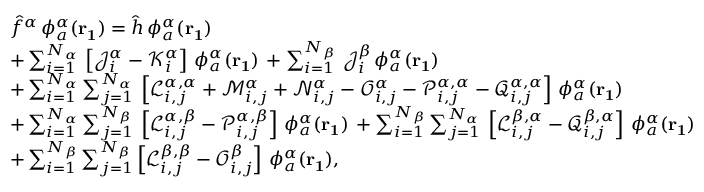<formula> <loc_0><loc_0><loc_500><loc_500>\begin{array} { r l } & { \hat { f } ^ { \alpha } \, \phi _ { a } ^ { \alpha } ( r _ { 1 } ) = \hat { h } \, \phi _ { a } ^ { \alpha } ( r _ { 1 } ) } \\ & { + \sum _ { i = 1 } ^ { N _ { \alpha } } \, \left [ \mathcal { J } _ { i } ^ { \alpha } - \mathcal { K } _ { i } ^ { \alpha } \right ] \, \phi _ { a } ^ { \alpha } ( r _ { 1 } ) \, + \sum _ { i = 1 } ^ { N _ { \beta } } \, \mathcal { J } _ { i } ^ { \beta } \, \phi _ { a } ^ { \alpha } ( r _ { 1 } ) } \\ & { + \sum _ { i = 1 } ^ { N _ { \alpha } } \sum _ { j = 1 } ^ { N _ { \alpha } } \, \left [ \mathcal { L } _ { i , j } ^ { \alpha , \alpha } + \mathcal { M } _ { i , j } ^ { \alpha } + \mathcal { N } _ { i , j } ^ { \alpha } - \mathcal { O } _ { i , j } ^ { \alpha } - \mathcal { P } _ { i , j } ^ { \alpha , \alpha } - \mathcal { Q } _ { i , j } ^ { \alpha , \alpha } \right ] \, \phi _ { a } ^ { \alpha } ( r _ { 1 } ) } \\ & { + \sum _ { i = 1 } ^ { N _ { \alpha } } \sum _ { j = 1 } ^ { N _ { \beta } } \, \left [ \mathcal { L } _ { i , j } ^ { \alpha , \beta } - \mathcal { P } _ { i , j } ^ { \alpha , \beta } \right ] \, \phi _ { a } ^ { \alpha } ( r _ { 1 } ) \, + \sum _ { i = 1 } ^ { N _ { \beta } } \sum _ { j = 1 } ^ { N _ { \alpha } } \, \left [ \mathcal { L } _ { i , j } ^ { \beta , \alpha } - \mathcal { Q } _ { i , j } ^ { \beta , \alpha } \right ] \, \phi _ { a } ^ { \alpha } ( r _ { 1 } ) } \\ & { + \sum _ { i = 1 } ^ { N _ { \beta } } \sum _ { j = 1 } ^ { N _ { \beta } } \left [ \mathcal { L } _ { i , j } ^ { \beta , \beta } - \mathcal { O } _ { i , j } ^ { \beta } \right ] \, \phi _ { a } ^ { \alpha } ( r _ { 1 } ) , } \end{array}</formula> 